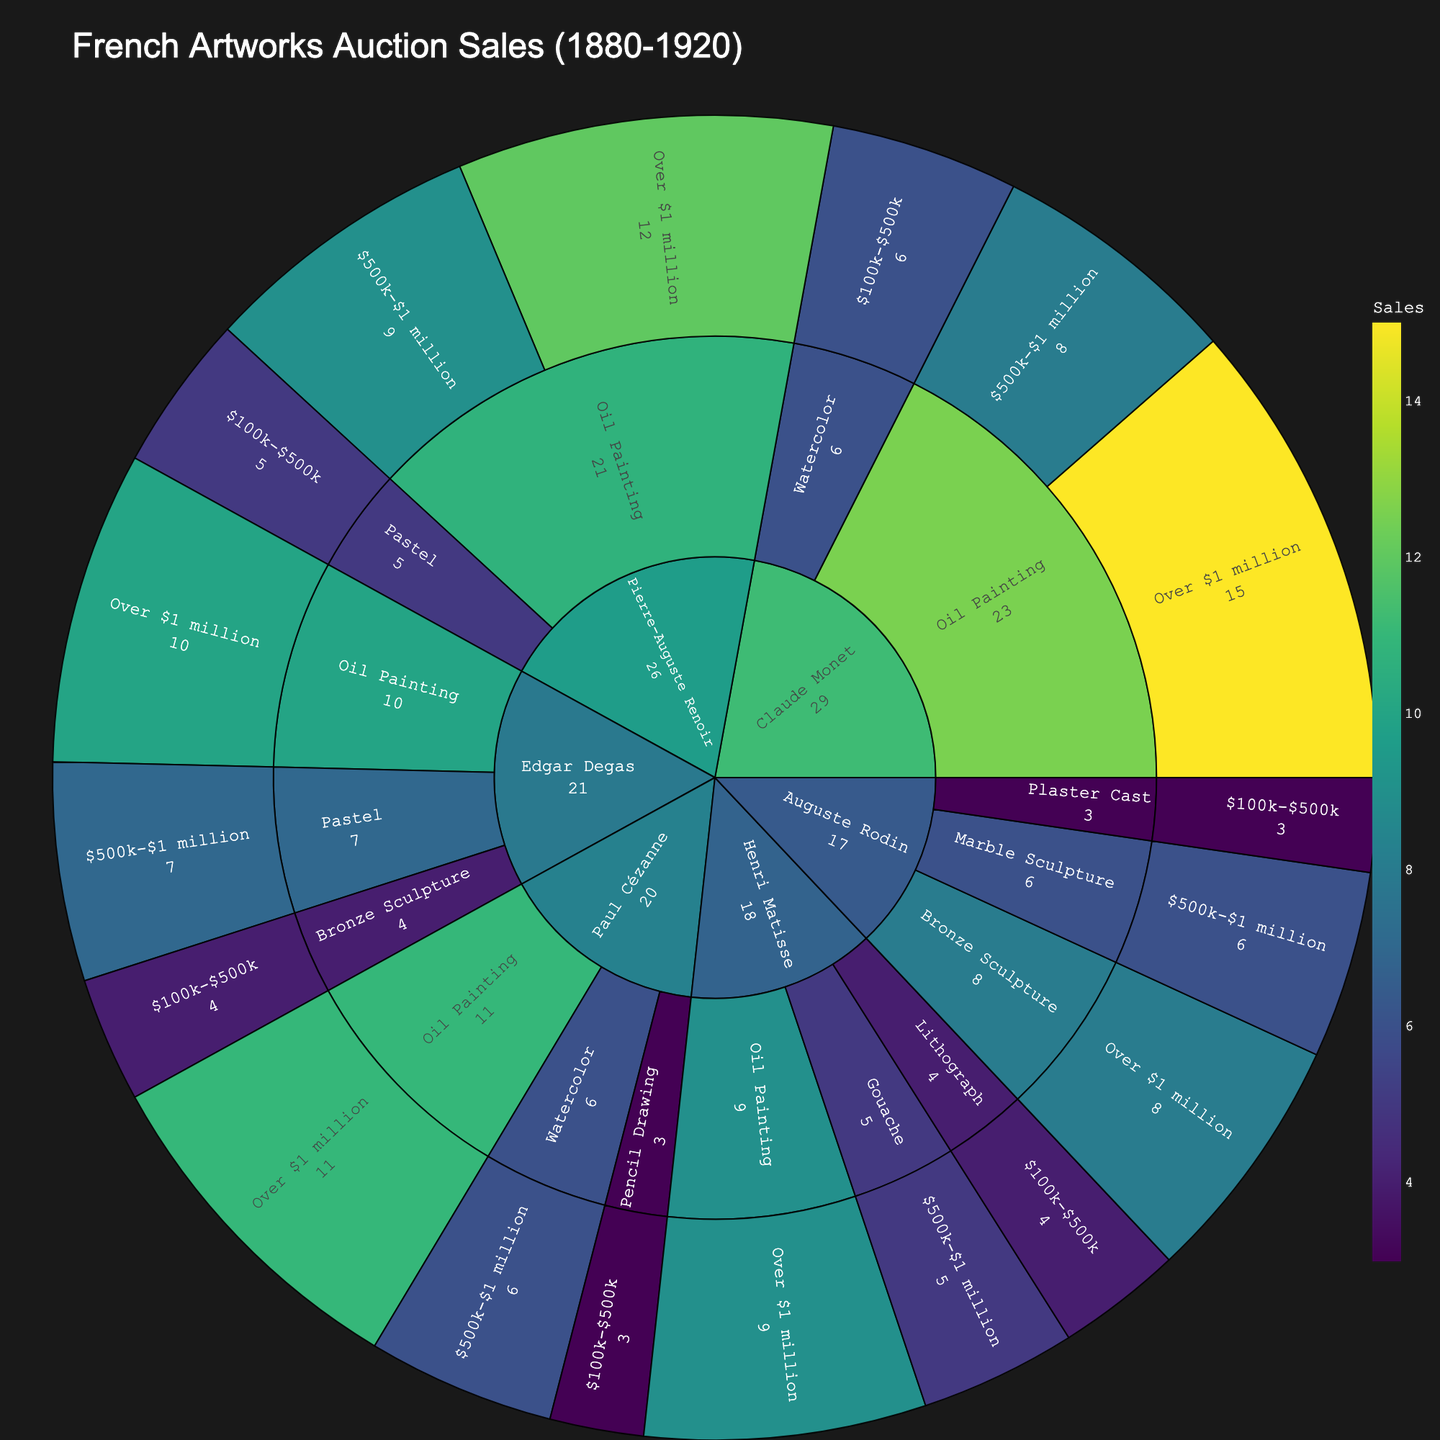What is the title of the sunburst plot? The title of the sunburst plot is typically displayed at the top center of the figure. In this case, the title is specified in the plot configuration.
Answer: French Artworks Auction Sales (1880-1920) Which artist has the highest number of sales for oil paintings over $1 million? By examining the sectors under "Over $1 million" for each artist, you can see which artist has the largest number of sales in this category. Claude Monet has 15 sales for oil paintings over $1 million.
Answer: Claude Monet How many total sales are there for artworks by Edgar Degas? Sum the sales for each medium and price range for Edgar Degas. The total is 10 (Oil Painting, Over $1 million) + 7 (Pastel, $500k-$1 million) + 4 (Bronze Sculpture, $100k-$500k).
Answer: 21 Which medium does Auguste Rodin have the highest number of total sales in? By looking at the inner circles of the sunburst plot for Auguste Rodin, we compare the total sales in each medium. The highest is in "Bronze Sculpture" with 8 sales.
Answer: Bronze Sculpture Compare the number of sales for oil paintings priced over $1 million by Pierre-Auguste Renoir and Paul Cézanne. Who has more sales? Check the sectors under "Over $1 million" for oil paintings for both Pierre-Auguste Renoir (12 sales) and Paul Cézanne (11 sales). Renoir has more sales.
Answer: Pierre-Auguste Renoir Which price range has the least number of sales for Paul Cézanne? Look at the sectors within Paul Cézanne's category and sum the sales for each price range. The smallest sector's value is for "$100k-$500k" with 3 sales.
Answer: $100k-$500k How many total sales were made for watercolor artworks across all artists? Sum the sales for all watercolor artworks: 6 (Claude Monet) + 6 (Paul Cézanne). The total is 6 + 6 = 12.
Answer: 12 Identify the artist with the lowest number of sales in the category "$500k-$1 million". Compare the "$500k-$1 million" category sales across all artists. Henri Matisse has the lowest number with 5 sales.
Answer: Henri Matisse If you sum the sales of watercolors by Claude Monet and pastels by Edgar Degas, what is the total? Add the number of sales for Claude Monet's watercolors (6) and Edgar Degas's pastels (7): 6 + 7 = 13.
Answer: 13 